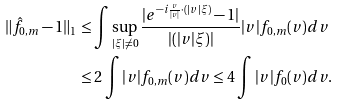<formula> <loc_0><loc_0><loc_500><loc_500>\| \hat { f } _ { 0 , m } - 1 \| _ { 1 } & \leq \int \sup _ { | \xi | \ne 0 } \frac { | e ^ { - i \frac { v } { | v | } \cdot ( | v | \xi ) } - 1 | } { \left | ( | v | \xi ) \right | } | v | f _ { 0 , m } ( v ) d v \\ & \leq 2 \int | v | f _ { 0 , m } ( v ) d v \leq 4 \int | v | f _ { 0 } ( v ) d v .</formula> 